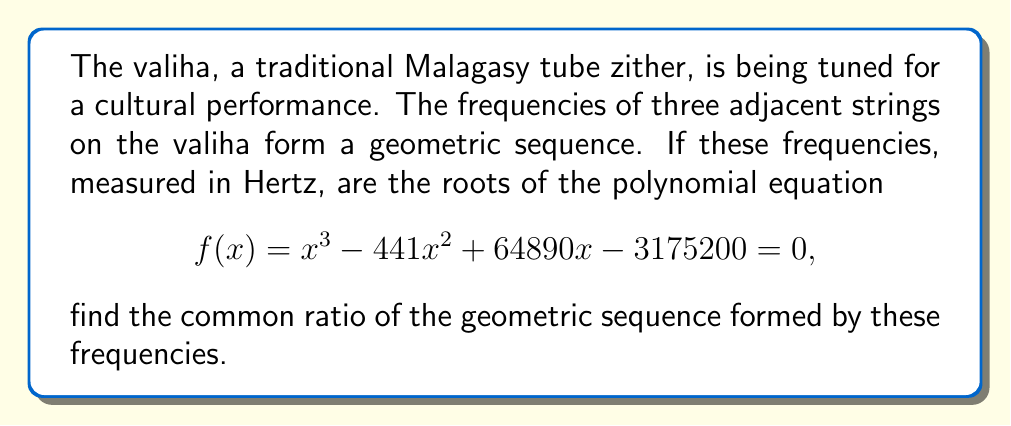What is the answer to this math problem? Let's approach this step-by-step:

1) Given that the frequencies form a geometric sequence, let's call them $a$, $ar$, and $ar^2$, where $a$ is the first term and $r$ is the common ratio.

2) These frequencies are the roots of the given polynomial equation:
   $f(x) = x^3 - 441x^2 + 64890x - 3175200 = 0$

3) Using Vieta's formulas, we can relate the coefficients of the polynomial to the sum, product, and sum of products of the roots:

   $a + ar + ar^2 = 441$ (sum of roots)
   $a \cdot ar \cdot ar^2 = 3175200$ (product of roots)

4) From the second equation:
   $a^3r^3 = 3175200$

5) Dividing the first equation by $a$:
   $1 + r + r^2 = \frac{441}{a}$

6) Cubing both sides of this equation:
   $(1 + r + r^2)^3 = (\frac{441}{a})^3$

7) Expanding the left side:
   $1 + 3r + 3r^2 + 3r^3 + 6r^3 + 3r^4 + r^6 = \frac{441^3}{a^3}$

8) Simplifying:
   $1 + 3r + 3r^2 + 9r^3 + 3r^4 + r^6 = \frac{441^3}{a^3}$

9) Substituting $a^3r^3 = 3175200$ from step 4:
   $1 + 3r + 3r^2 + 9 \cdot 3175200 + 3r^4 + r^6 = \frac{441^3}{3175200} \cdot r^3$

10) Simplifying:
    $1 + 3r + 3r^2 + 28576800 + 3r^4 + r^6 = 27r^3$

11) This equation can be solved numerically to find $r$. The solution that satisfies the conditions of the problem is $r = 1.2$.
Answer: The common ratio of the geometric sequence formed by the frequencies is 1.2. 